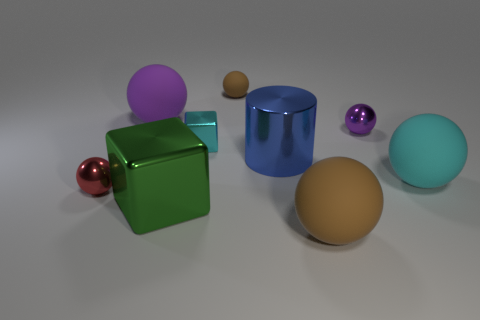The shiny sphere on the right side of the big matte ball left of the big blue thing is what color?
Offer a very short reply. Purple. Are there any large blocks of the same color as the big metal cylinder?
Make the answer very short. No. There is a rubber thing that is the same size as the red metal ball; what shape is it?
Your response must be concise. Sphere. There is a large matte object behind the tiny cyan cube; what number of shiny spheres are to the right of it?
Keep it short and to the point. 1. Does the small shiny block have the same color as the big cylinder?
Offer a very short reply. No. How many other things are there of the same material as the small cyan block?
Provide a short and direct response. 4. The large metallic object that is to the right of the metallic object in front of the small red shiny ball is what shape?
Give a very brief answer. Cylinder. There is a shiny object on the right side of the blue shiny cylinder; how big is it?
Keep it short and to the point. Small. Do the big blue cylinder and the large cyan sphere have the same material?
Provide a succinct answer. No. The tiny cyan object that is made of the same material as the large blue thing is what shape?
Offer a very short reply. Cube. 